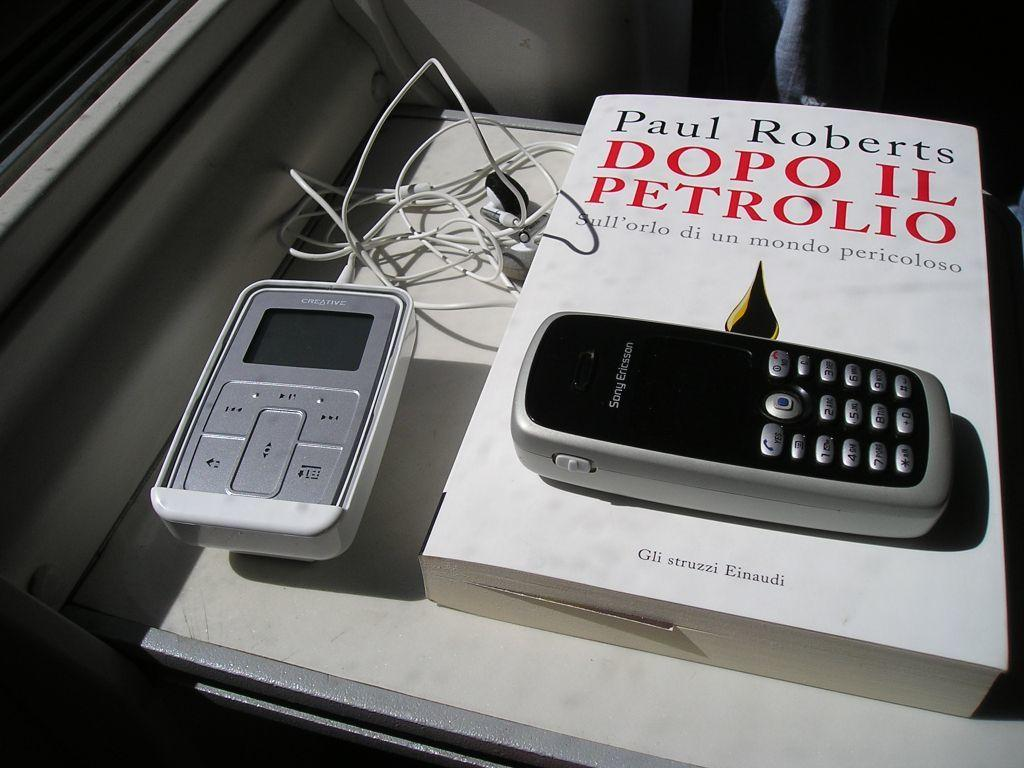<image>
Give a short and clear explanation of the subsequent image. a book titled 'dopo il petrolio' by paul roberts 